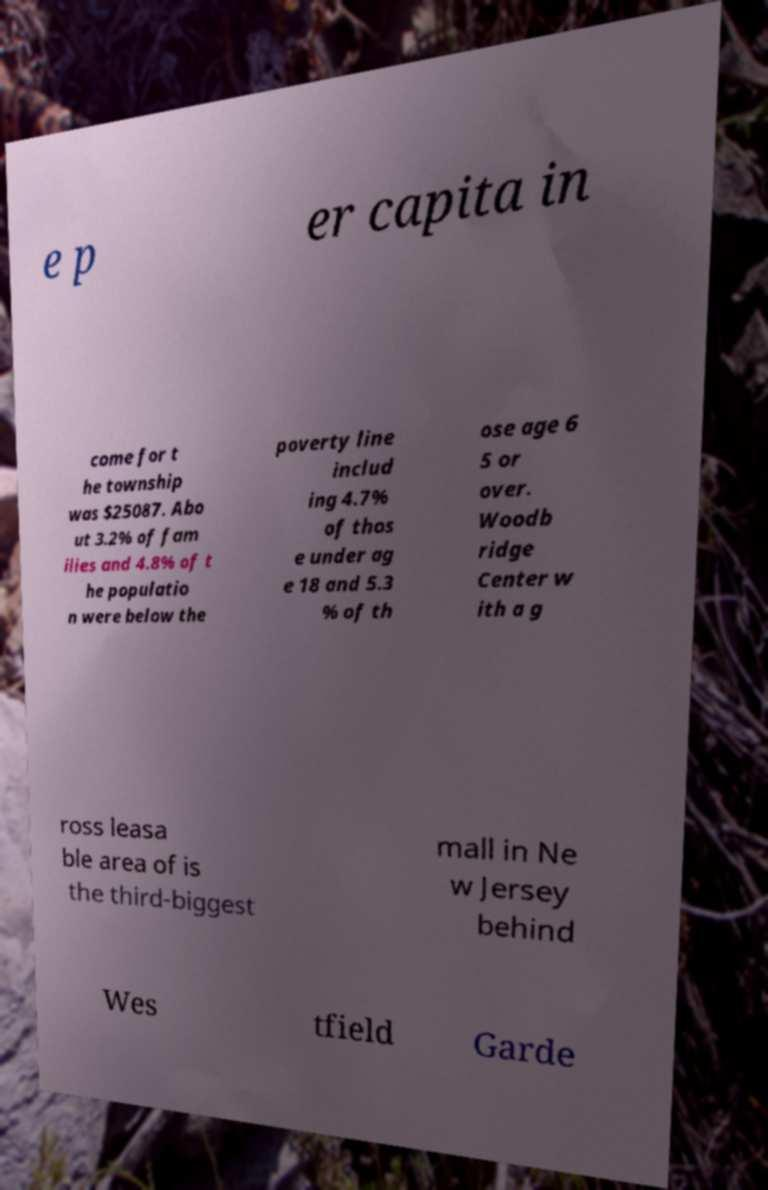Please read and relay the text visible in this image. What does it say? e p er capita in come for t he township was $25087. Abo ut 3.2% of fam ilies and 4.8% of t he populatio n were below the poverty line includ ing 4.7% of thos e under ag e 18 and 5.3 % of th ose age 6 5 or over. Woodb ridge Center w ith a g ross leasa ble area of is the third-biggest mall in Ne w Jersey behind Wes tfield Garde 